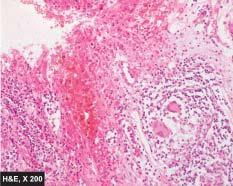what are the histological features present?
Answer the question using a single word or phrase. Transmural chronic inflammatory cell infiltration 